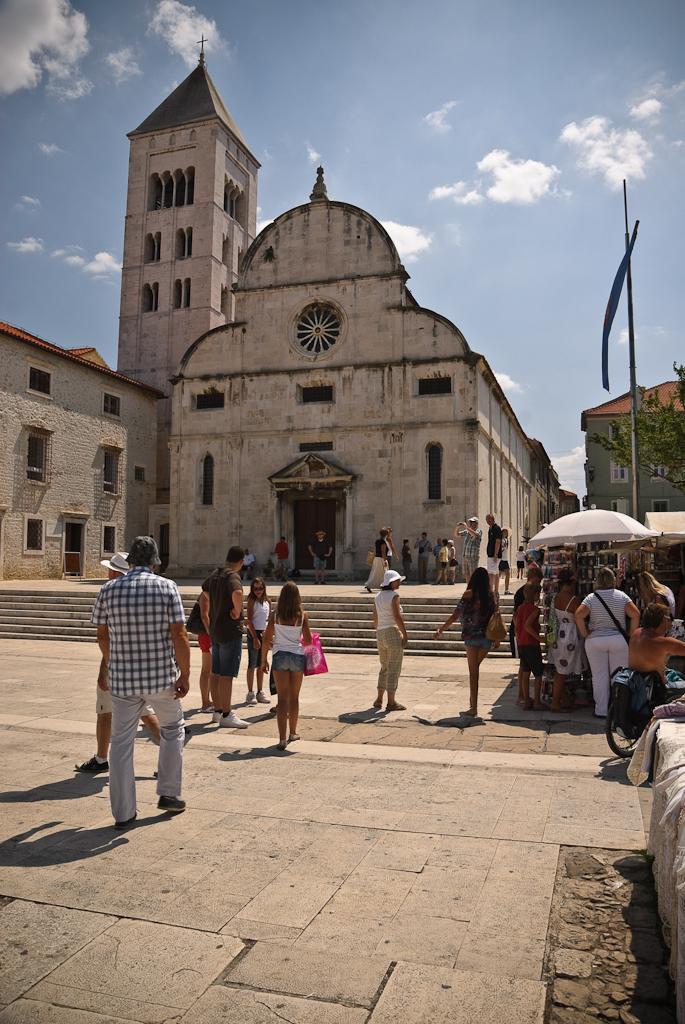Can you describe this image briefly? In this image, we can see a group of people are walking on the land. On the right side, we can see a group of people standing in front of a stall. On the right side, we can also see an umbrella, flag, trees. In the background, we can see a building, a group of people. At the top, we can see a sky which is a bit cloudy. At the bottom, we can see a staircase and a land. 